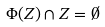Convert formula to latex. <formula><loc_0><loc_0><loc_500><loc_500>\Phi ( Z ) \cap Z = \emptyset</formula> 